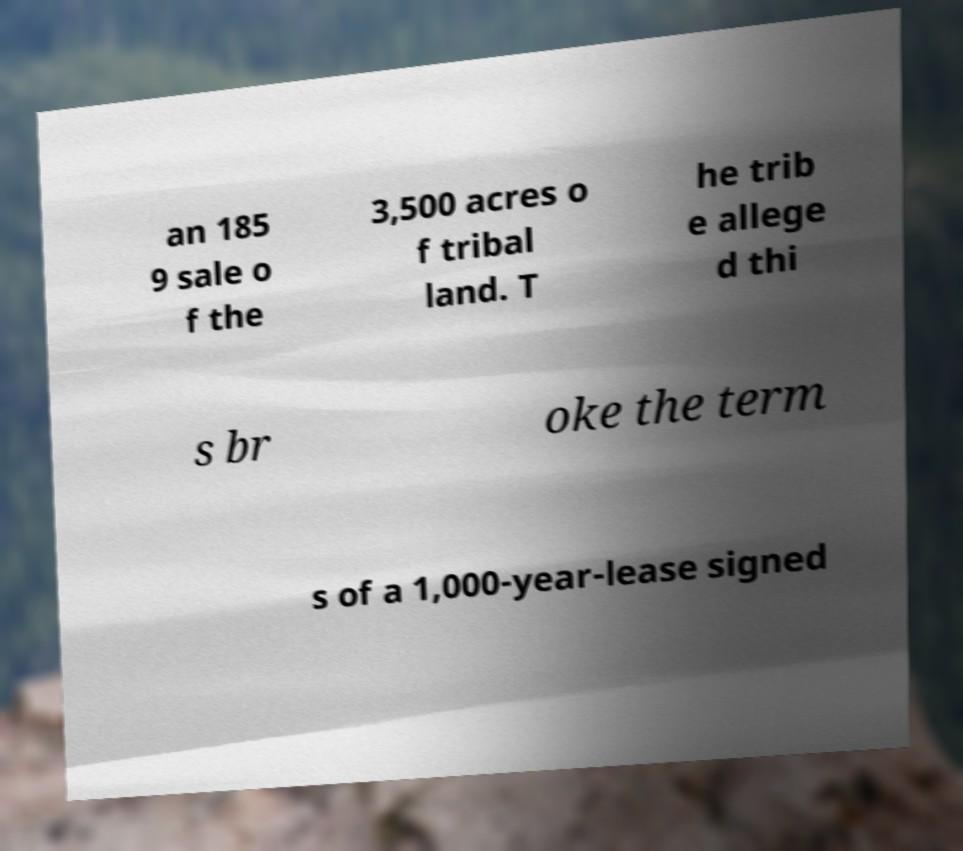I need the written content from this picture converted into text. Can you do that? an 185 9 sale o f the 3,500 acres o f tribal land. T he trib e allege d thi s br oke the term s of a 1,000-year-lease signed 